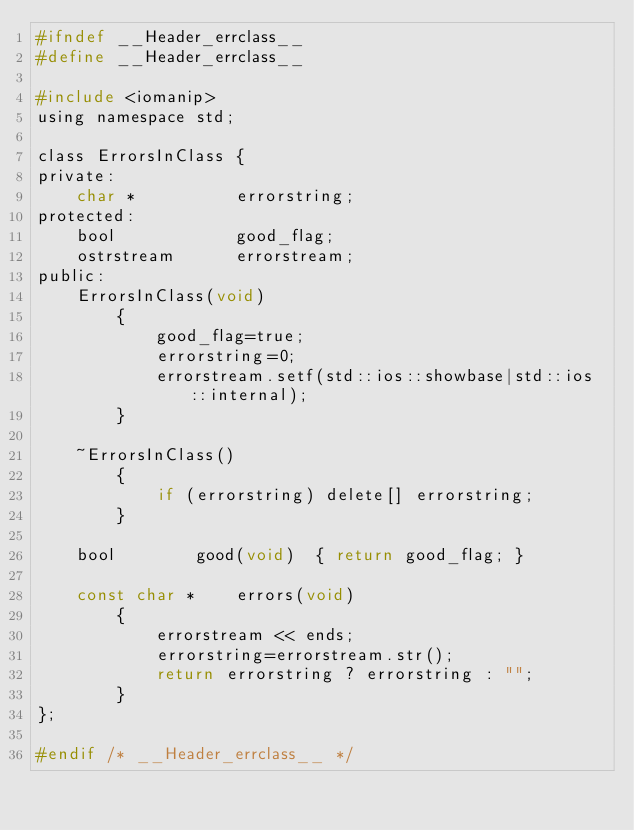<code> <loc_0><loc_0><loc_500><loc_500><_C_>#ifndef __Header_errclass__
#define __Header_errclass__

#include <iomanip>
using namespace std;

class ErrorsInClass {
private:
	char *			errorstring;
protected:
	bool 			good_flag;
	ostrstream 		errorstream;
public:
	ErrorsInClass(void)
		{
			good_flag=true;
			errorstring=0;
			errorstream.setf(std::ios::showbase|std::ios::internal);
		}

	~ErrorsInClass()
		{
			if (errorstring) delete[] errorstring;
		}

	bool		good(void)	{ return good_flag; }

	const char *	errors(void)
		{
			errorstream << ends;
			errorstring=errorstream.str();
			return errorstring ? errorstring : "";
		}
};

#endif /* __Header_errclass__ */
</code> 